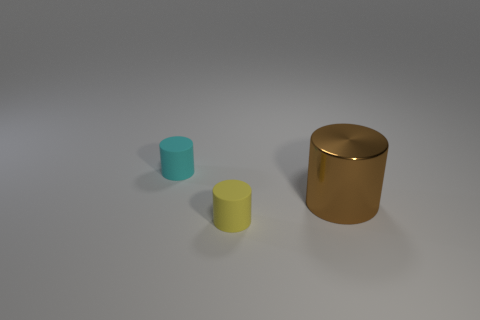Add 1 small green matte blocks. How many objects exist? 4 Add 1 blue shiny cylinders. How many blue shiny cylinders exist? 1 Subtract 1 cyan cylinders. How many objects are left? 2 Subtract all cylinders. Subtract all tiny blue matte cylinders. How many objects are left? 0 Add 3 large brown cylinders. How many large brown cylinders are left? 4 